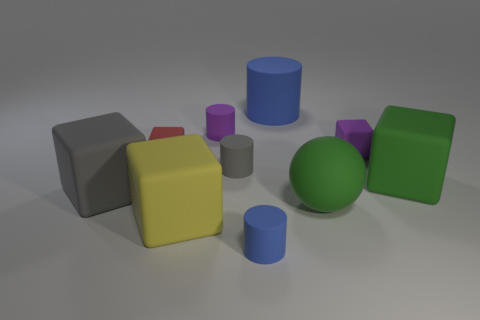How big is the green cube?
Give a very brief answer. Large. Is the material of the blue cylinder on the right side of the tiny blue cylinder the same as the tiny red object?
Your answer should be compact. Yes. Is the large blue object the same shape as the small red matte thing?
Keep it short and to the point. No. What is the shape of the purple thing that is to the right of the blue matte cylinder that is behind the tiny purple matte object that is on the left side of the big matte cylinder?
Give a very brief answer. Cube. Does the blue thing that is in front of the big yellow matte object have the same shape as the green object in front of the big green matte block?
Keep it short and to the point. No. Is there a tiny gray cube made of the same material as the purple cylinder?
Provide a short and direct response. No. The big cube that is on the right side of the big blue object behind the small matte cylinder in front of the gray matte cube is what color?
Ensure brevity in your answer.  Green. Are the small thing to the left of the purple cylinder and the small thing in front of the yellow matte object made of the same material?
Your answer should be very brief. Yes. There is a blue matte object that is behind the yellow cube; what shape is it?
Your answer should be very brief. Cylinder. What number of things are tiny blue matte cylinders or blue rubber cylinders that are behind the purple cube?
Keep it short and to the point. 2. 